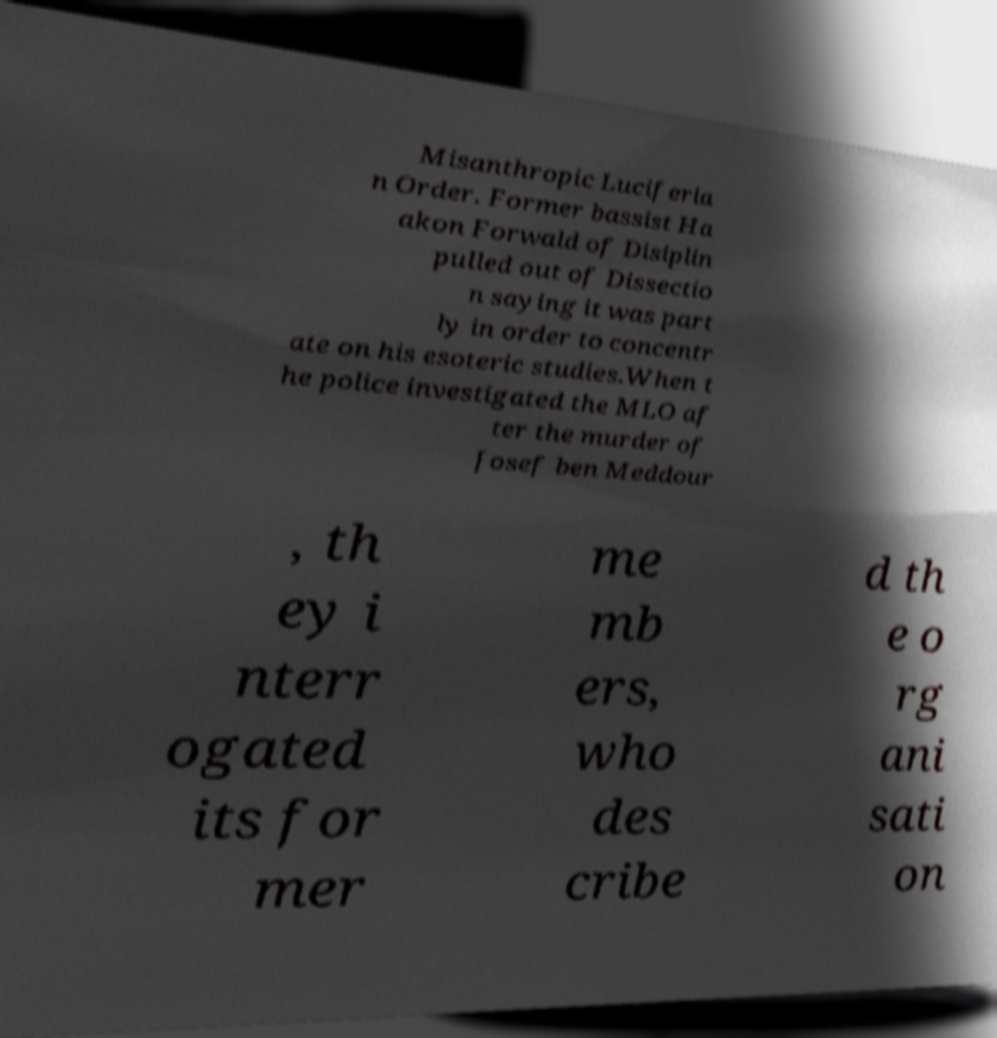There's text embedded in this image that I need extracted. Can you transcribe it verbatim? Misanthropic Luciferia n Order. Former bassist Ha akon Forwald of Disiplin pulled out of Dissectio n saying it was part ly in order to concentr ate on his esoteric studies.When t he police investigated the MLO af ter the murder of Josef ben Meddour , th ey i nterr ogated its for mer me mb ers, who des cribe d th e o rg ani sati on 